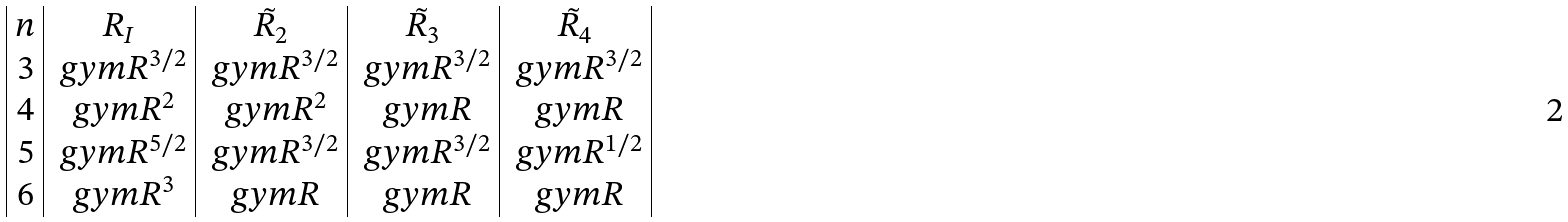<formula> <loc_0><loc_0><loc_500><loc_500>\begin{array} { | c | c | c | c | c | c | } n & R _ { I } & \tilde { R } _ { 2 } & \tilde { R } _ { 3 } & \tilde { R } _ { 4 } \\ 3 & \ g y m R ^ { 3 / 2 } & \ g y m R ^ { 3 / 2 } & \ g y m R ^ { 3 / 2 } & \ g y m R ^ { 3 / 2 } \\ 4 & \ g y m R ^ { 2 } & \ g y m R ^ { 2 } & \ g y m R & \ g y m R \\ 5 & \ g y m R ^ { 5 / 2 } & \ g y m R ^ { 3 / 2 } & \ g y m R ^ { 3 / 2 } & \ g y m R ^ { 1 / 2 } \\ 6 & \ g y m R ^ { 3 } & \ g y m R & \ g y m R & \ g y m R \\ \end{array}</formula> 